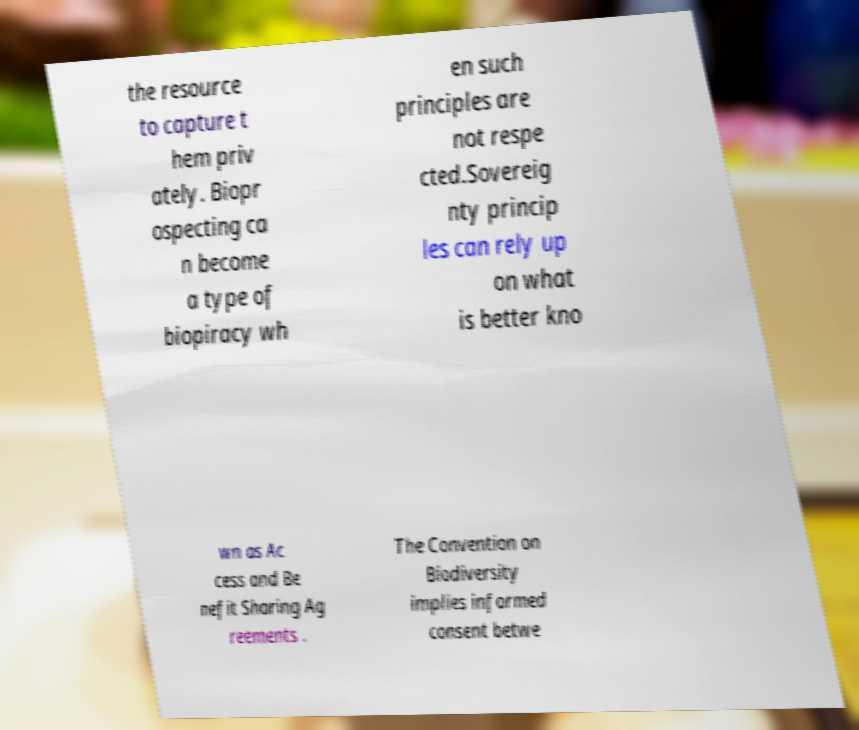Could you extract and type out the text from this image? the resource to capture t hem priv ately. Biopr ospecting ca n become a type of biopiracy wh en such principles are not respe cted.Sovereig nty princip les can rely up on what is better kno wn as Ac cess and Be nefit Sharing Ag reements . The Convention on Biodiversity implies informed consent betwe 